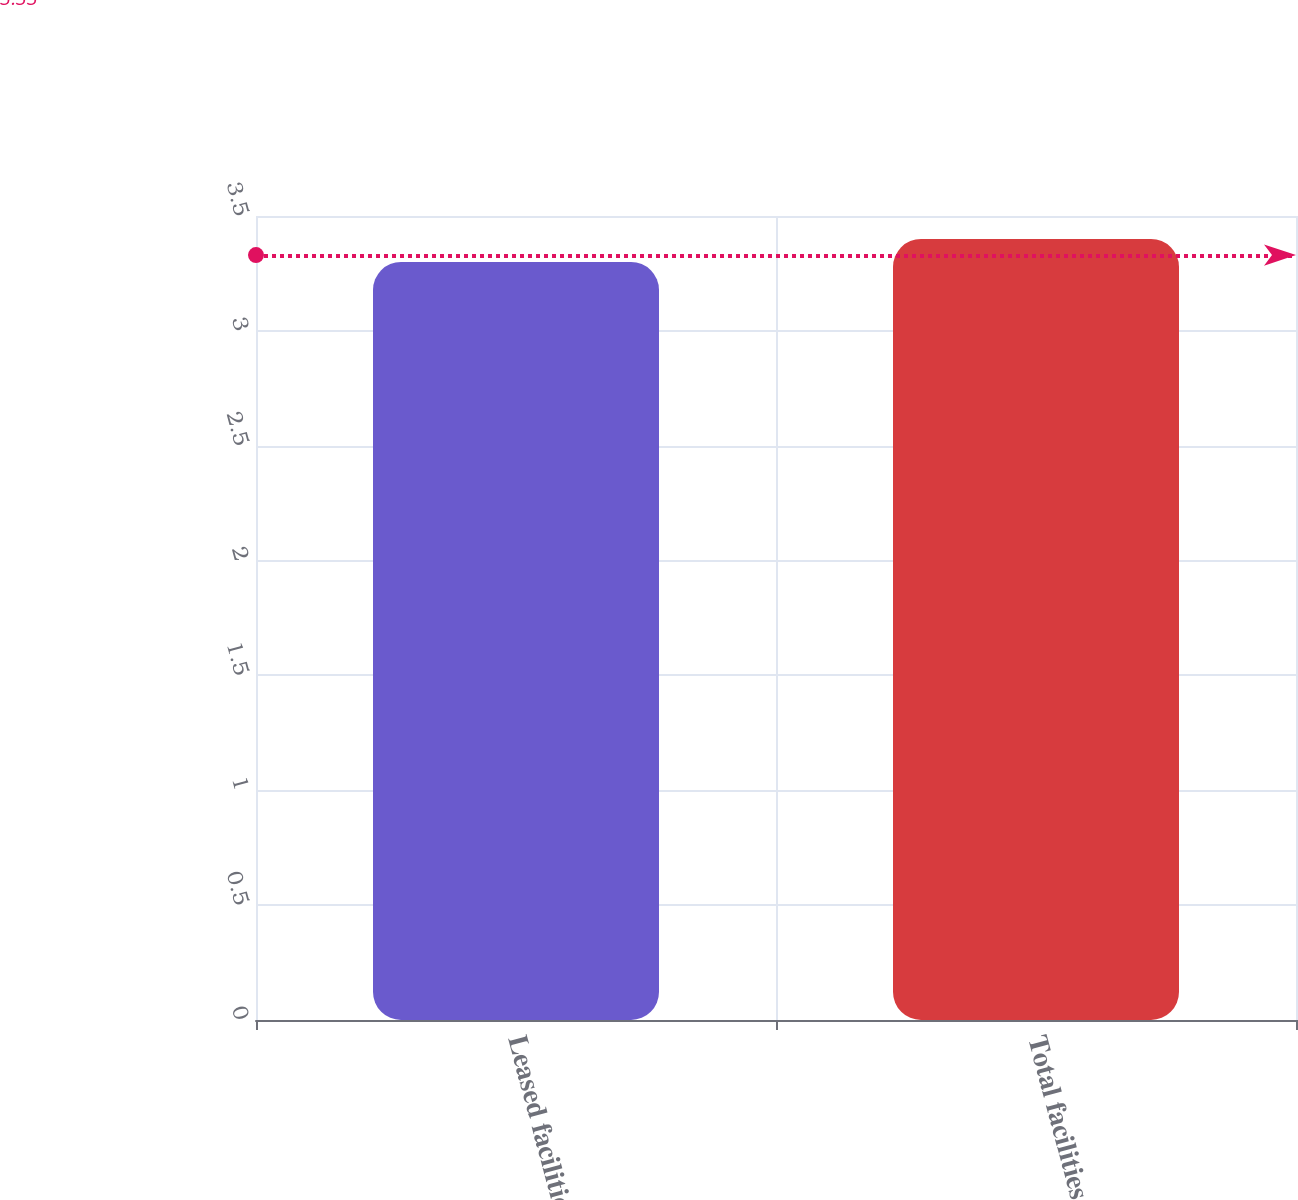<chart> <loc_0><loc_0><loc_500><loc_500><bar_chart><fcel>Leased facilities<fcel>Total facilities<nl><fcel>3.3<fcel>3.4<nl></chart> 